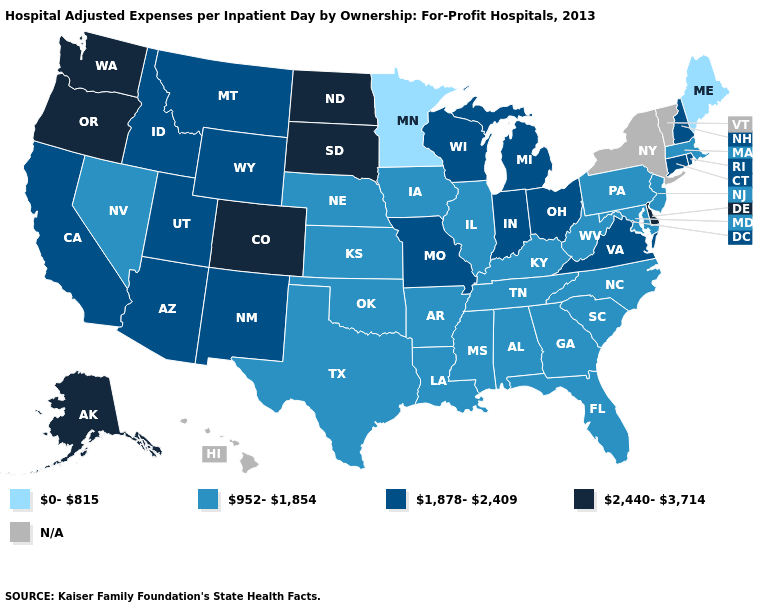What is the value of New Hampshire?
Short answer required. 1,878-2,409. Name the states that have a value in the range N/A?
Keep it brief. Hawaii, New York, Vermont. What is the value of Louisiana?
Keep it brief. 952-1,854. Name the states that have a value in the range 1,878-2,409?
Answer briefly. Arizona, California, Connecticut, Idaho, Indiana, Michigan, Missouri, Montana, New Hampshire, New Mexico, Ohio, Rhode Island, Utah, Virginia, Wisconsin, Wyoming. Name the states that have a value in the range 1,878-2,409?
Keep it brief. Arizona, California, Connecticut, Idaho, Indiana, Michigan, Missouri, Montana, New Hampshire, New Mexico, Ohio, Rhode Island, Utah, Virginia, Wisconsin, Wyoming. Name the states that have a value in the range N/A?
Short answer required. Hawaii, New York, Vermont. Does the map have missing data?
Be succinct. Yes. Name the states that have a value in the range 1,878-2,409?
Write a very short answer. Arizona, California, Connecticut, Idaho, Indiana, Michigan, Missouri, Montana, New Hampshire, New Mexico, Ohio, Rhode Island, Utah, Virginia, Wisconsin, Wyoming. What is the value of Minnesota?
Concise answer only. 0-815. What is the value of Alaska?
Quick response, please. 2,440-3,714. Does Minnesota have the lowest value in the USA?
Give a very brief answer. Yes. Among the states that border West Virginia , which have the lowest value?
Quick response, please. Kentucky, Maryland, Pennsylvania. 